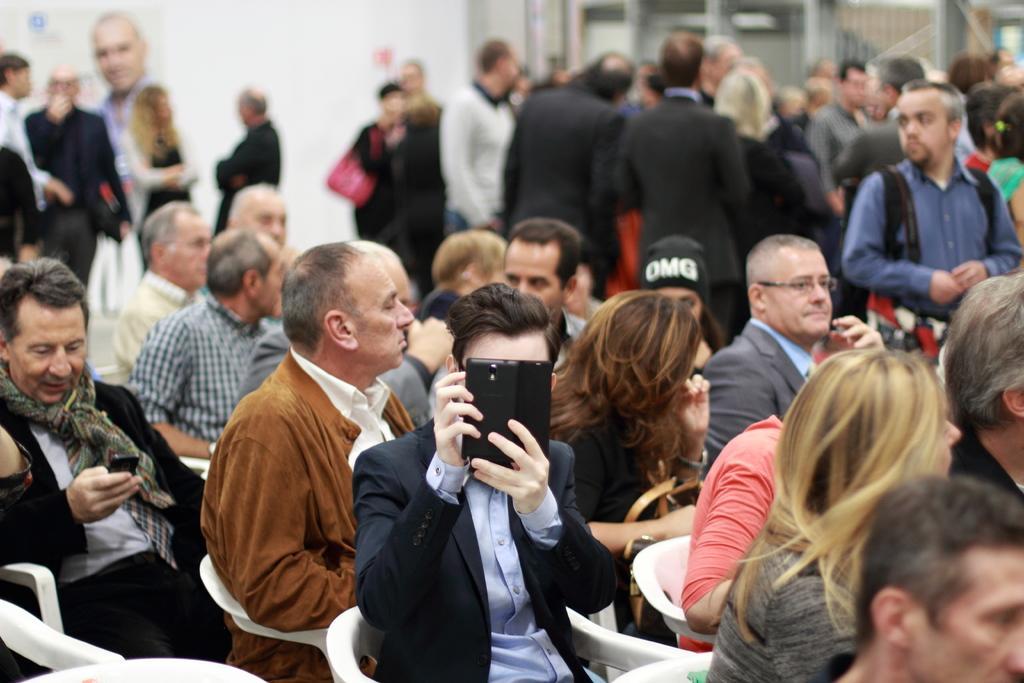Can you describe this image briefly? In this image we can see a person sitting and holding a mobile phone in the center. We can also see many people sitting on the chairs. In the background we can see people standing. We can also see a person poster to the wall and some part of background is blurred. 